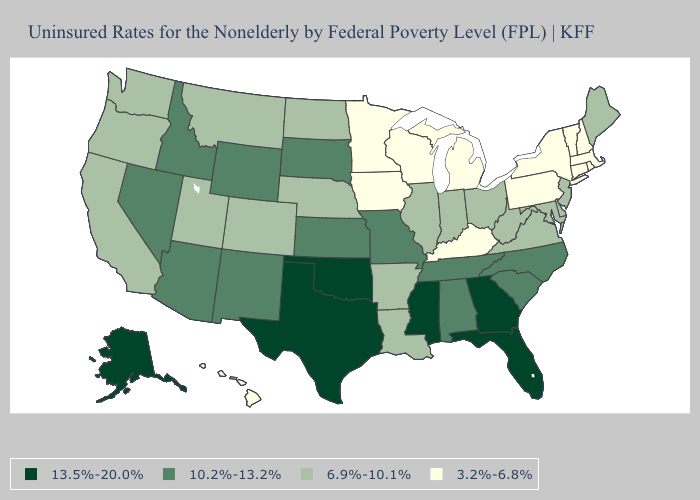Name the states that have a value in the range 10.2%-13.2%?
Concise answer only. Alabama, Arizona, Idaho, Kansas, Missouri, Nevada, New Mexico, North Carolina, South Carolina, South Dakota, Tennessee, Wyoming. Does Kentucky have the lowest value in the South?
Short answer required. Yes. What is the value of Montana?
Short answer required. 6.9%-10.1%. Name the states that have a value in the range 6.9%-10.1%?
Quick response, please. Arkansas, California, Colorado, Delaware, Illinois, Indiana, Louisiana, Maine, Maryland, Montana, Nebraska, New Jersey, North Dakota, Ohio, Oregon, Utah, Virginia, Washington, West Virginia. What is the highest value in the MidWest ?
Quick response, please. 10.2%-13.2%. Among the states that border California , which have the lowest value?
Be succinct. Oregon. Is the legend a continuous bar?
Be succinct. No. Does Connecticut have a lower value than California?
Concise answer only. Yes. What is the value of Wisconsin?
Concise answer only. 3.2%-6.8%. Name the states that have a value in the range 3.2%-6.8%?
Keep it brief. Connecticut, Hawaii, Iowa, Kentucky, Massachusetts, Michigan, Minnesota, New Hampshire, New York, Pennsylvania, Rhode Island, Vermont, Wisconsin. Which states hav the highest value in the West?
Write a very short answer. Alaska. What is the value of Maryland?
Short answer required. 6.9%-10.1%. What is the highest value in the USA?
Write a very short answer. 13.5%-20.0%. Does Pennsylvania have the lowest value in the Northeast?
Be succinct. Yes. What is the value of Alaska?
Concise answer only. 13.5%-20.0%. 